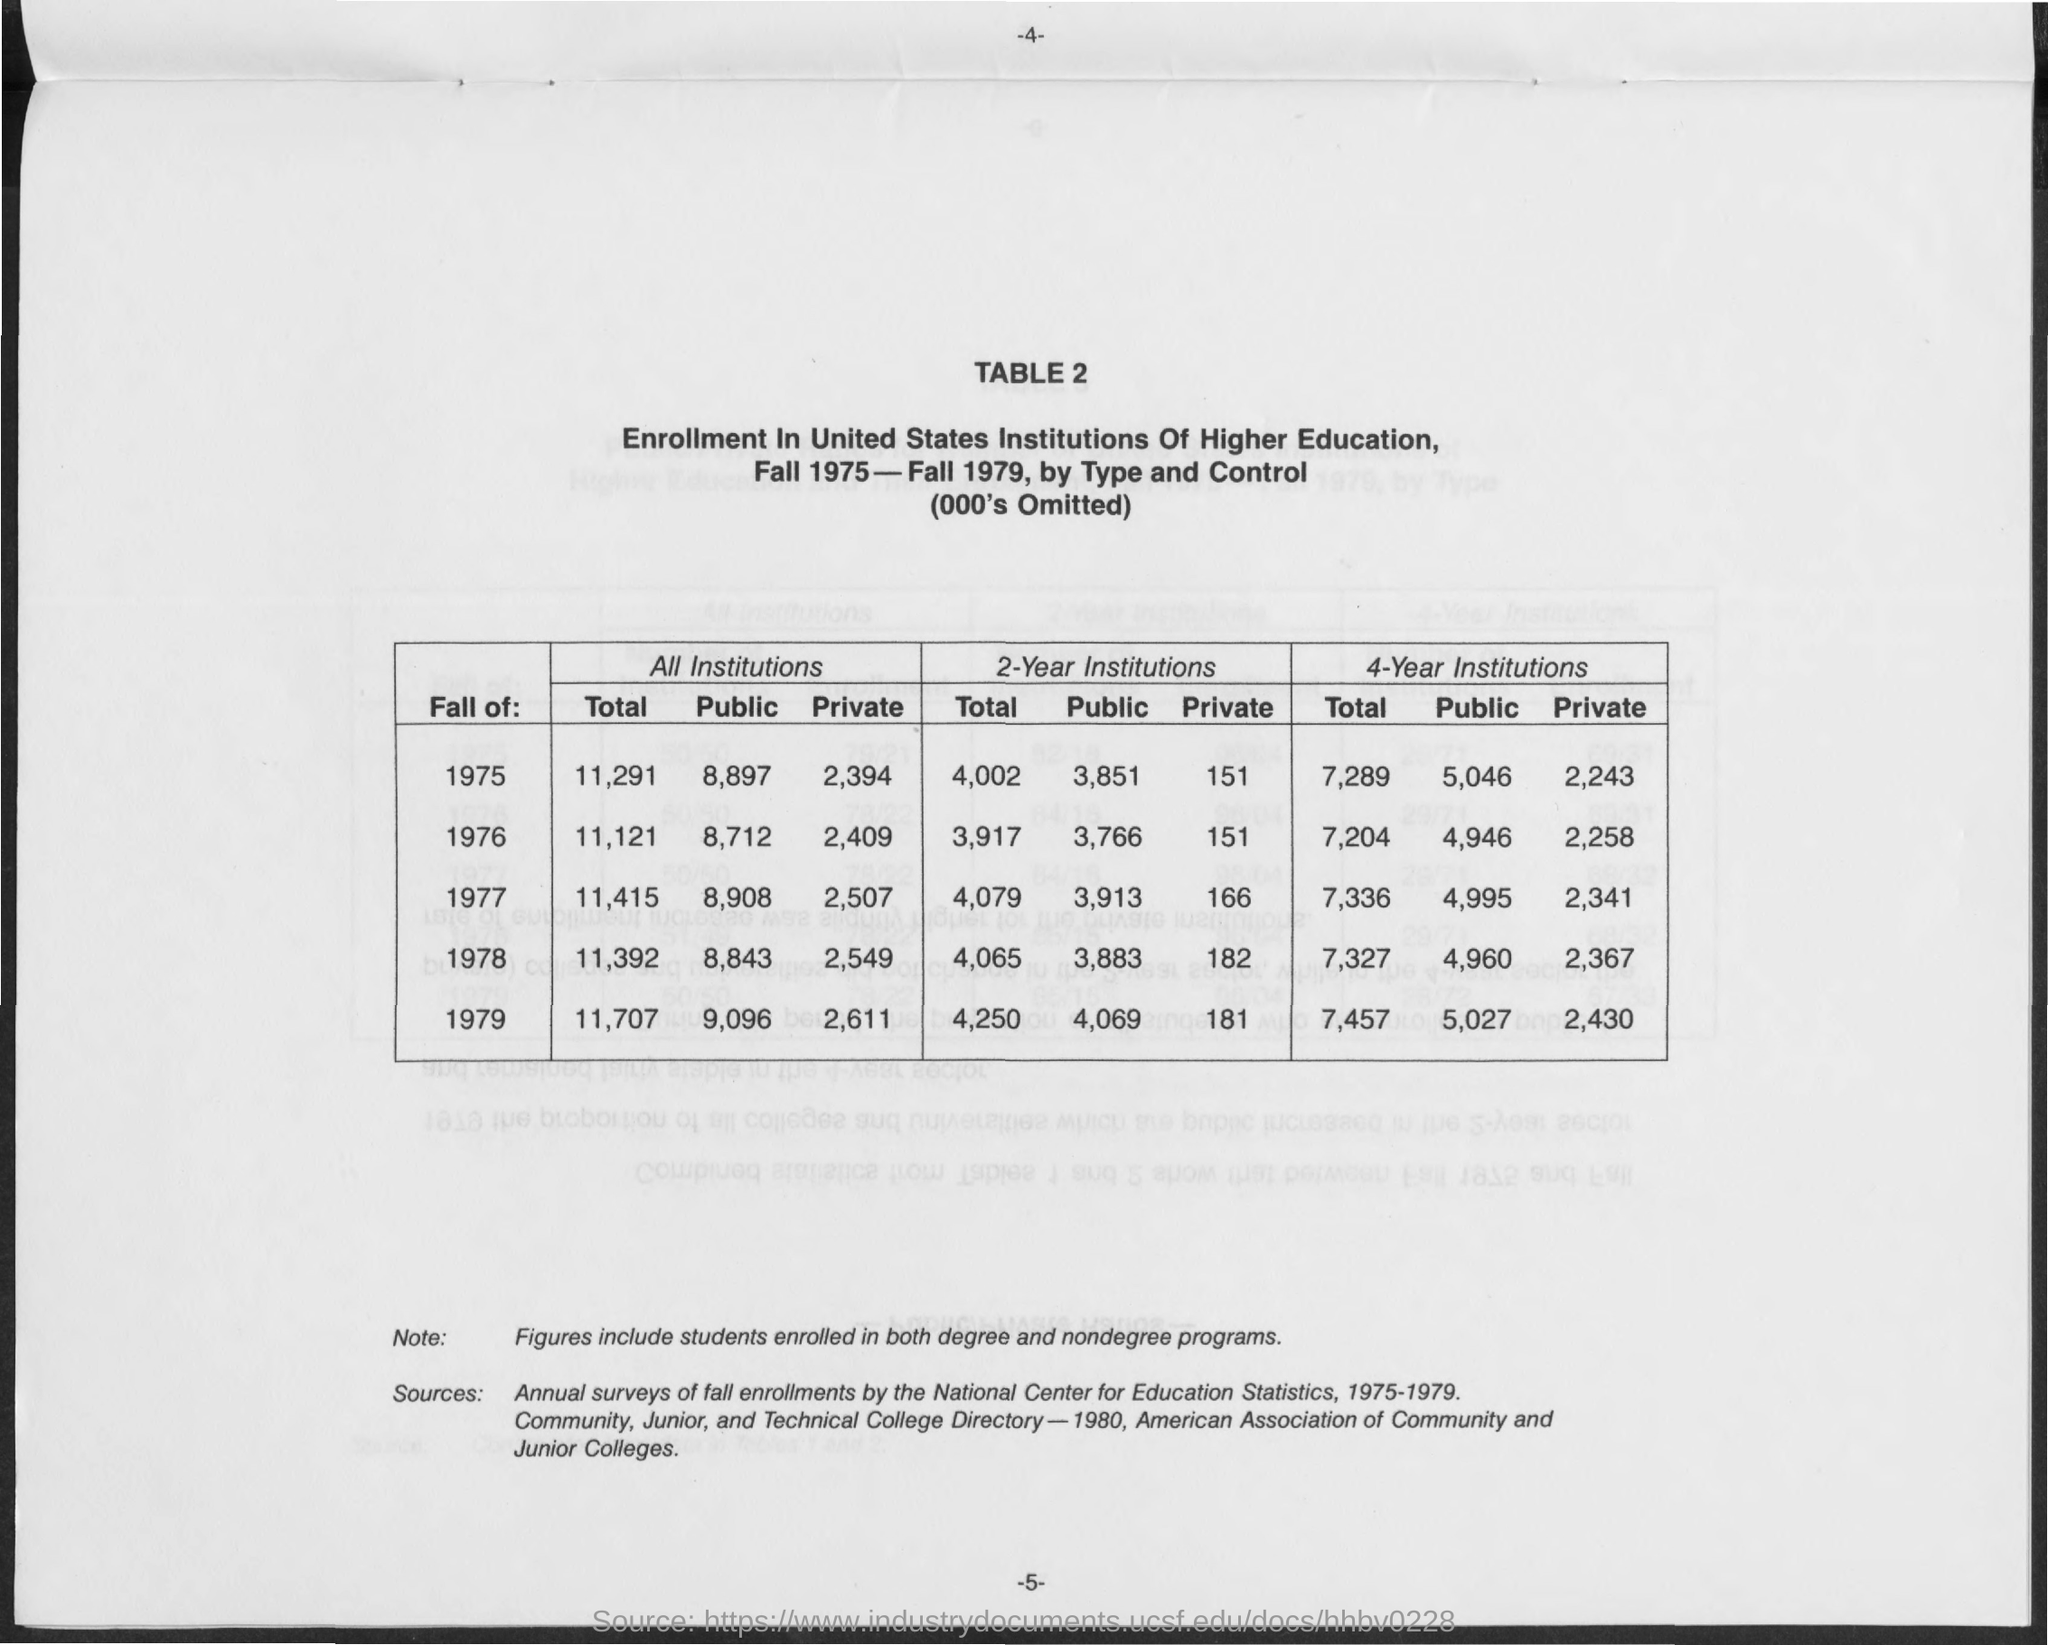What is the Total enrollment in All institutions during the Fall of 1975?
Make the answer very short. 11,291. What is the Total enrollment in All institutions during the Fall of 1976?
Ensure brevity in your answer.  11,121. What is the Total enrollment in All institutions during the Fall of 1977?
Provide a short and direct response. 11,415. What is the Total enrollment in All institutions during the Fall of 1978?
Offer a very short reply. 11,392. What is the Total enrollment in All institutions during the Fall of 1979?
Keep it short and to the point. 11,707. What is the Public enrollment in All institutions during the Fall of 1975?
Offer a terse response. 8,897. What is the Public enrollment in All institutions during the Fall of 1976?
Your response must be concise. 8,712. What is the Public enrollment in All institutions during the Fall of 1977?
Ensure brevity in your answer.  8,908. What is the Public enrollment in All institutions during the Fall of 1978?
Give a very brief answer. 8,843. What is the Public enrollment in All institutions during the Fall of 1979?
Your answer should be very brief. 9,096. 